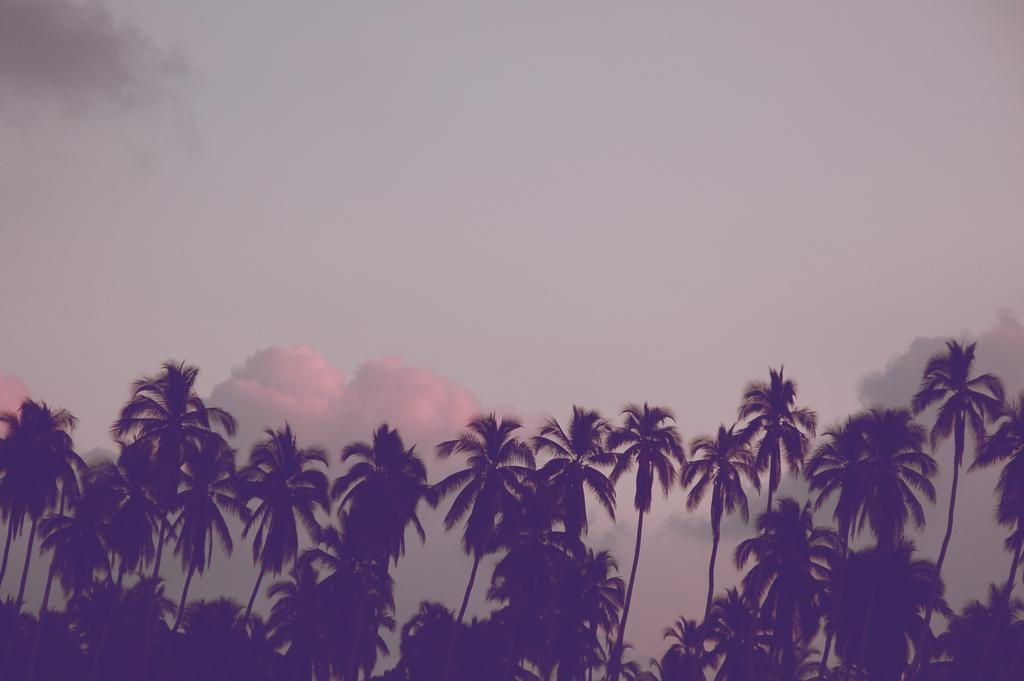What type of vegetation can be seen in the image? There are trees in the image. What part of the natural environment is visible in the image? The sky is visible in the image. What can be observed in the sky in the image? Clouds are present in the image. What type of skin is visible on the trees in the image? There is no skin visible on the trees in the image; trees have bark, not skin. 